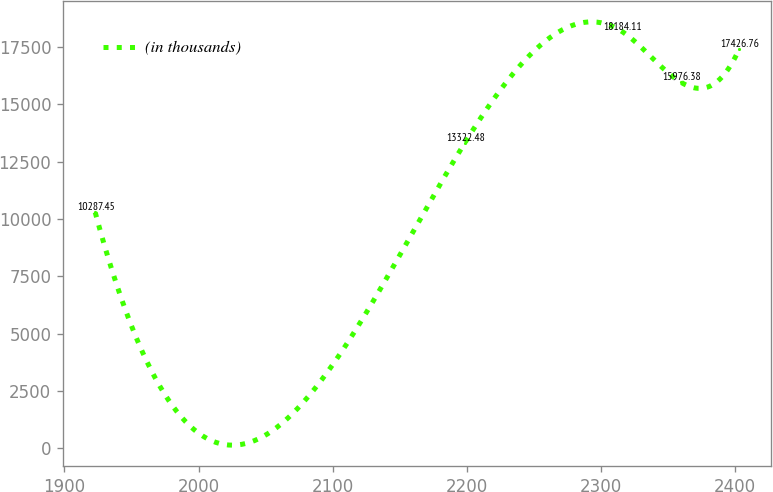<chart> <loc_0><loc_0><loc_500><loc_500><line_chart><ecel><fcel>(in thousands)<nl><fcel>1922.93<fcel>10287.5<nl><fcel>2198.59<fcel>13322.5<nl><fcel>2315.9<fcel>18184.1<nl><fcel>2359.6<fcel>15976.4<nl><fcel>2403.3<fcel>17426.8<nl></chart> 